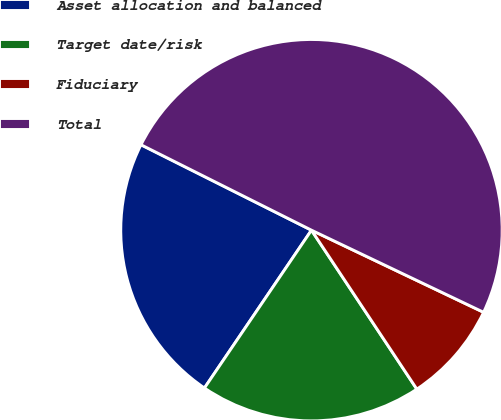Convert chart. <chart><loc_0><loc_0><loc_500><loc_500><pie_chart><fcel>Asset allocation and balanced<fcel>Target date/risk<fcel>Fiduciary<fcel>Total<nl><fcel>22.91%<fcel>18.8%<fcel>8.6%<fcel>49.69%<nl></chart> 